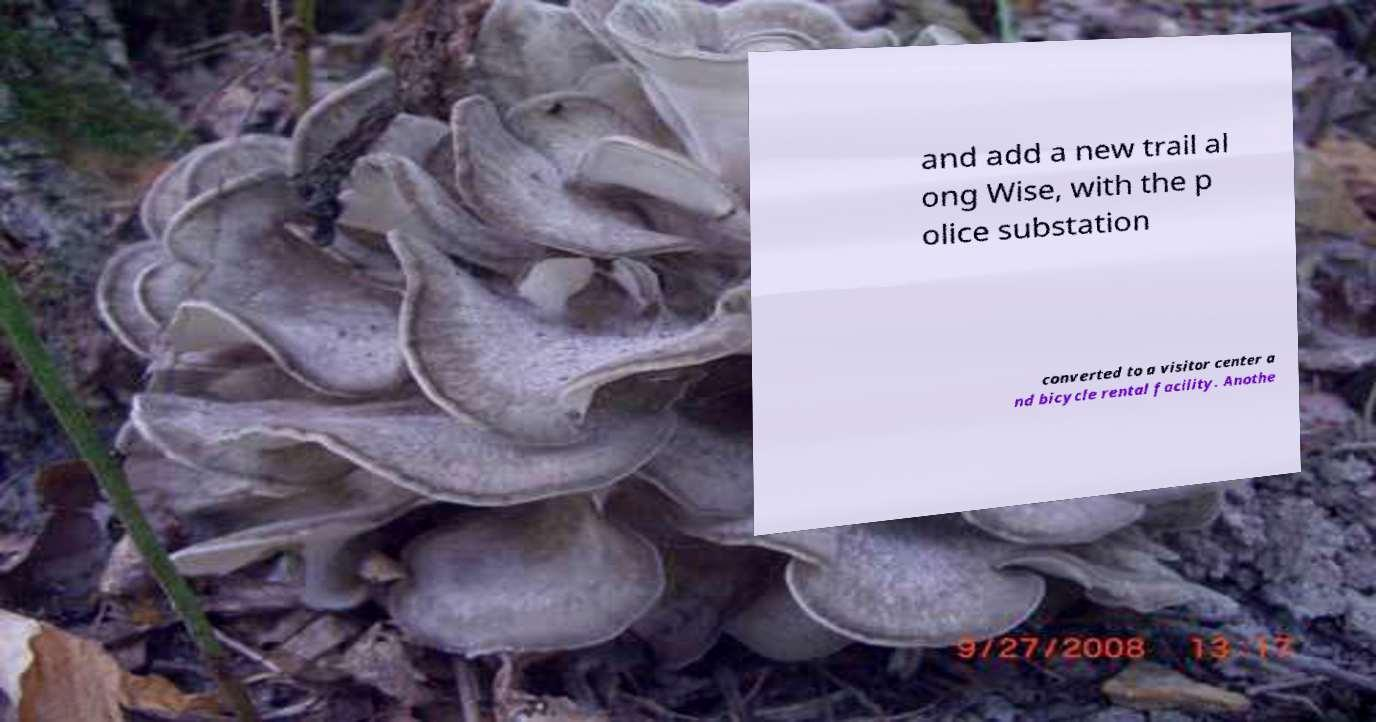I need the written content from this picture converted into text. Can you do that? and add a new trail al ong Wise, with the p olice substation converted to a visitor center a nd bicycle rental facility. Anothe 